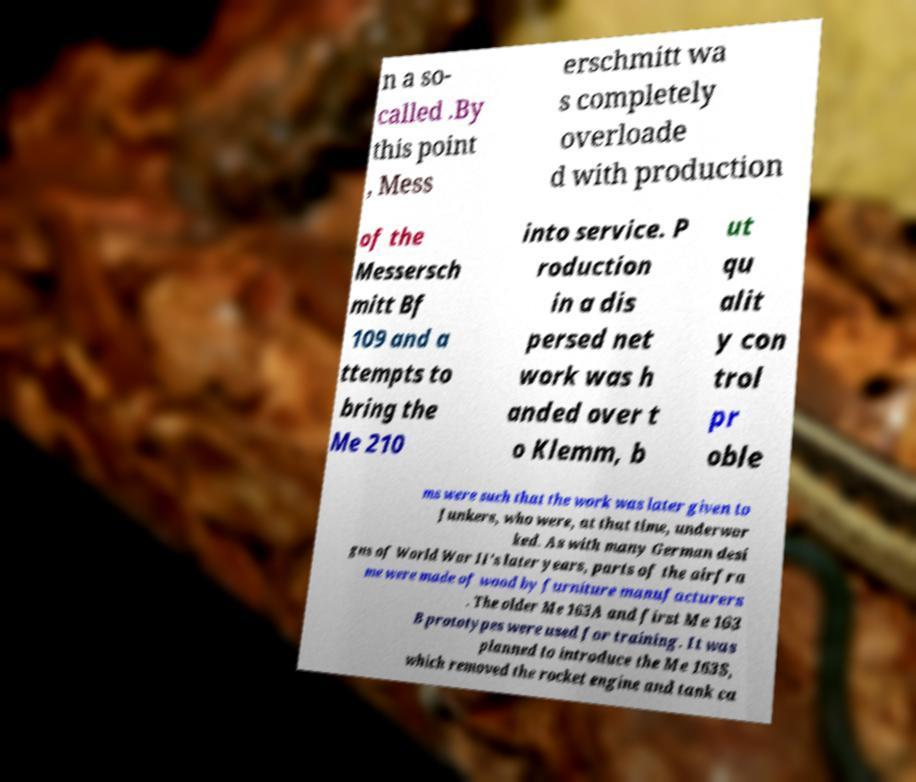I need the written content from this picture converted into text. Can you do that? n a so- called .By this point , Mess erschmitt wa s completely overloade d with production of the Messersch mitt Bf 109 and a ttempts to bring the Me 210 into service. P roduction in a dis persed net work was h anded over t o Klemm, b ut qu alit y con trol pr oble ms were such that the work was later given to Junkers, who were, at that time, underwor ked. As with many German desi gns of World War II's later years, parts of the airfra me were made of wood by furniture manufacturers . The older Me 163A and first Me 163 B prototypes were used for training. It was planned to introduce the Me 163S, which removed the rocket engine and tank ca 